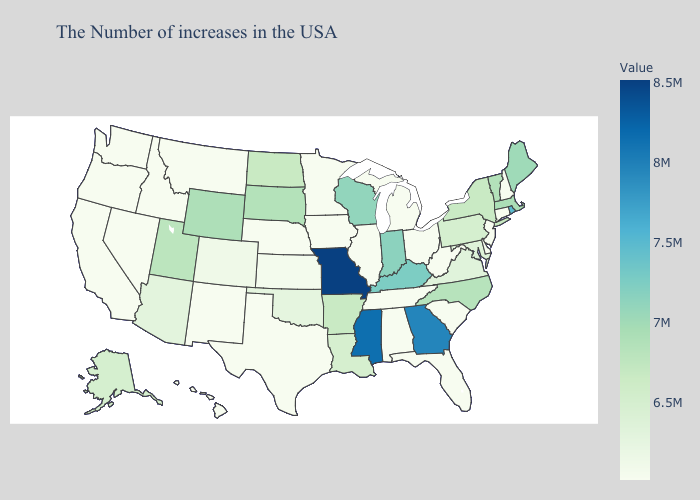Does Pennsylvania have the lowest value in the Northeast?
Short answer required. No. Which states have the lowest value in the South?
Keep it brief. Delaware, South Carolina, West Virginia, Florida, Alabama, Tennessee, Texas. Is the legend a continuous bar?
Short answer required. Yes. Does Hawaii have the lowest value in the USA?
Write a very short answer. Yes. Does Rhode Island have the lowest value in the Northeast?
Quick response, please. No. Does Missouri have the highest value in the MidWest?
Concise answer only. Yes. 